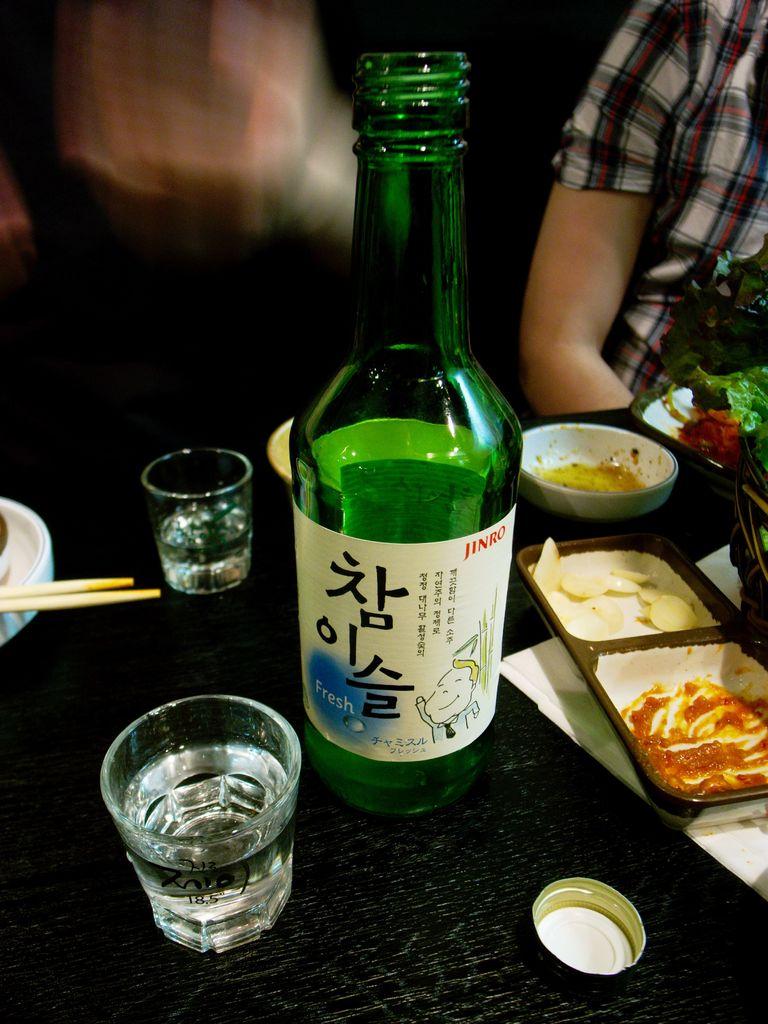What is the english word under the japanese characters?
Offer a very short reply. Fresh. 